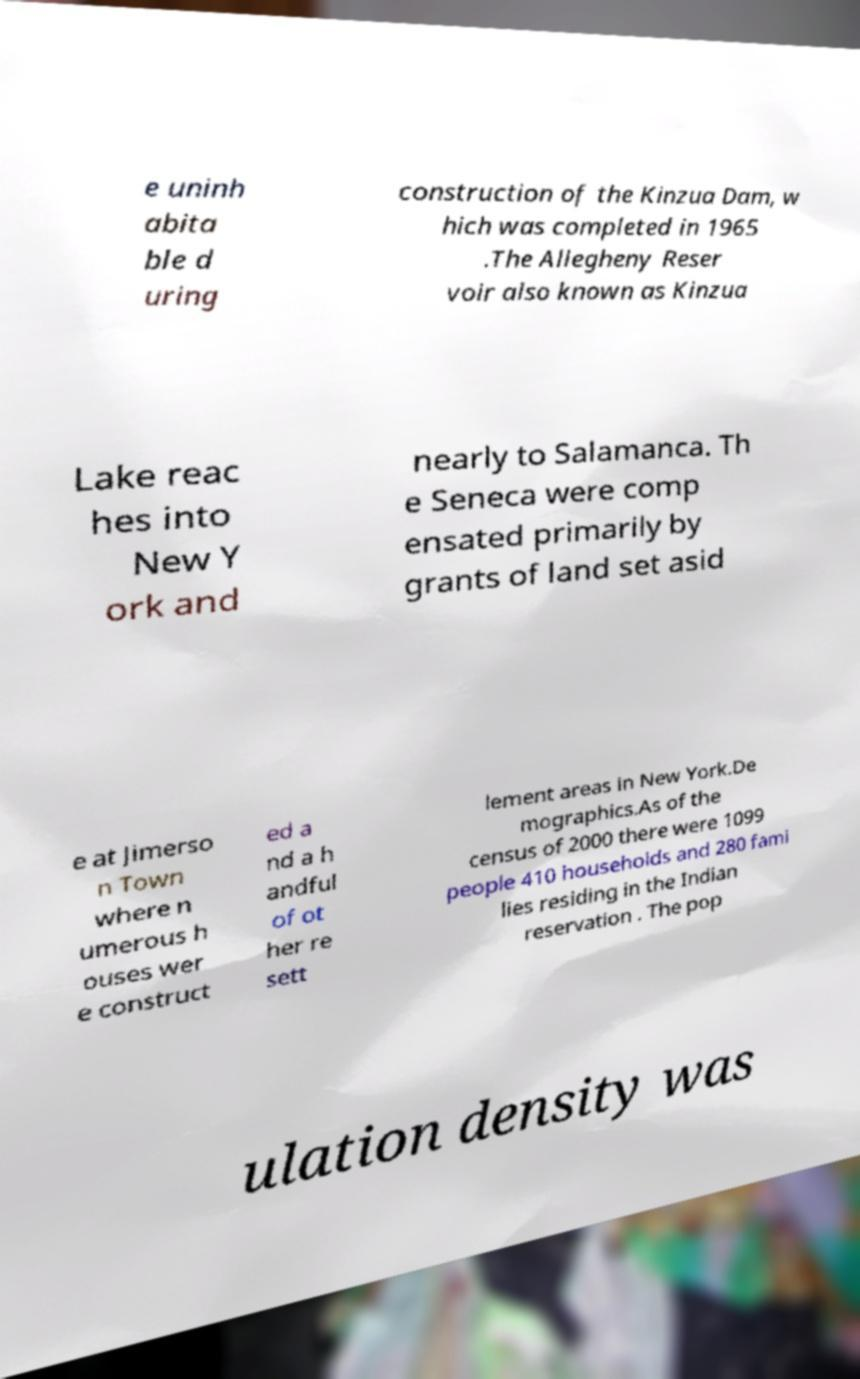There's text embedded in this image that I need extracted. Can you transcribe it verbatim? e uninh abita ble d uring construction of the Kinzua Dam, w hich was completed in 1965 .The Allegheny Reser voir also known as Kinzua Lake reac hes into New Y ork and nearly to Salamanca. Th e Seneca were comp ensated primarily by grants of land set asid e at Jimerso n Town where n umerous h ouses wer e construct ed a nd a h andful of ot her re sett lement areas in New York.De mographics.As of the census of 2000 there were 1099 people 410 households and 280 fami lies residing in the Indian reservation . The pop ulation density was 